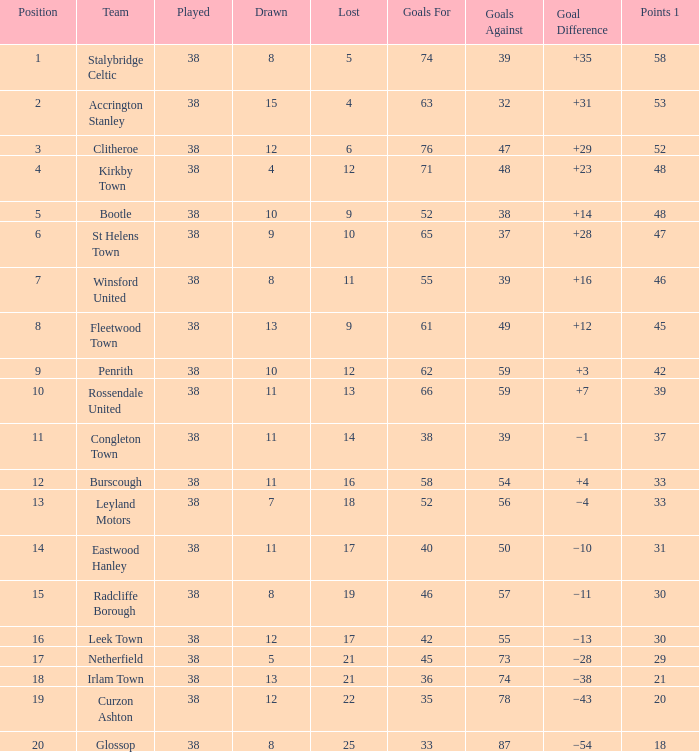What is the total number of losses for a draw of 7, and 1 points less than 33? 0.0. 